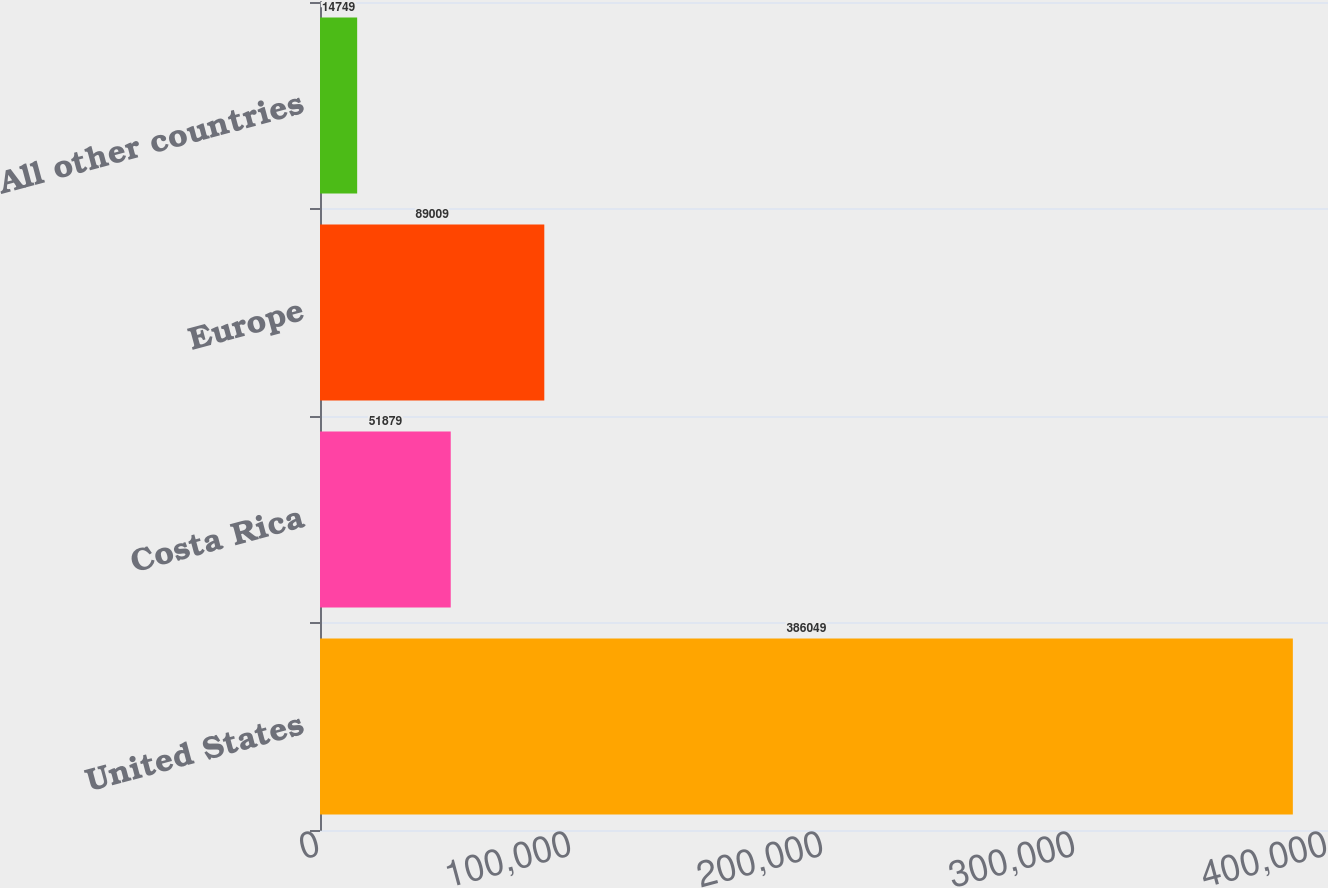Convert chart to OTSL. <chart><loc_0><loc_0><loc_500><loc_500><bar_chart><fcel>United States<fcel>Costa Rica<fcel>Europe<fcel>All other countries<nl><fcel>386049<fcel>51879<fcel>89009<fcel>14749<nl></chart> 